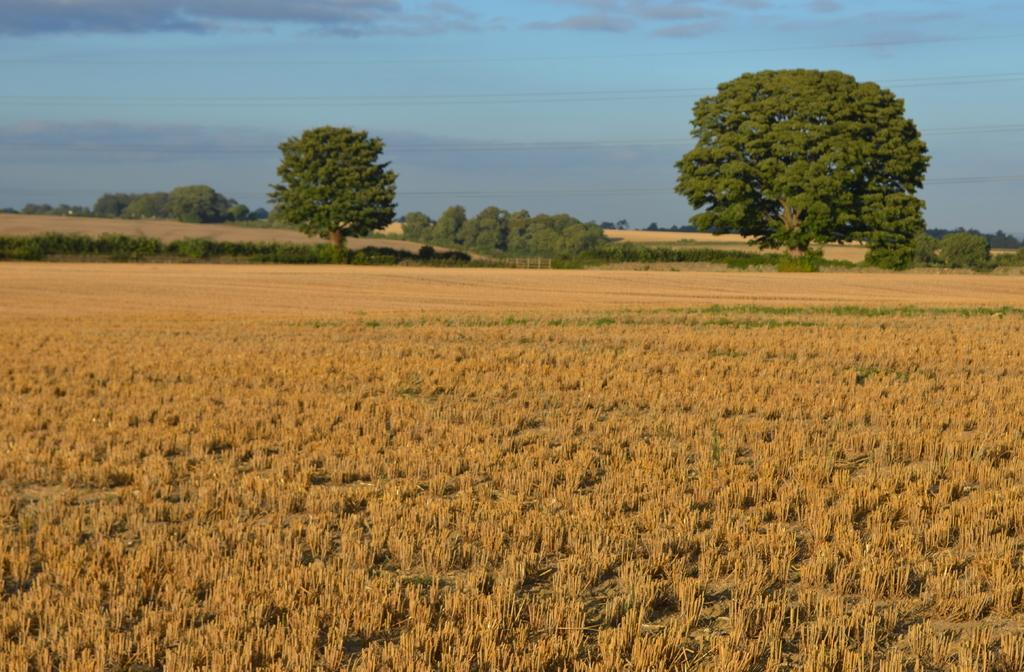What type of vegetation can be seen in the image? There are trees in the image. Can you describe any man-made structures in the image? There might be a fence in the image. What is visible at the top of the image? The sky is visible at the top of the image. What can be seen in the sky? There are clouds in the sky. What else is present in the image besides trees and clouds? Wires are present in the image. What is the ground covered with at the bottom of the image? Dried grass is visible at the bottom of the image. How many paint cans are being exchanged between the trees in the image? There are no paint cans or exchange of items depicted in the image; it features trees, clouds, sky, wires, and dried grass. What is the thumbprint on the fence in the image? There is no fence or thumbprint present in the image. 